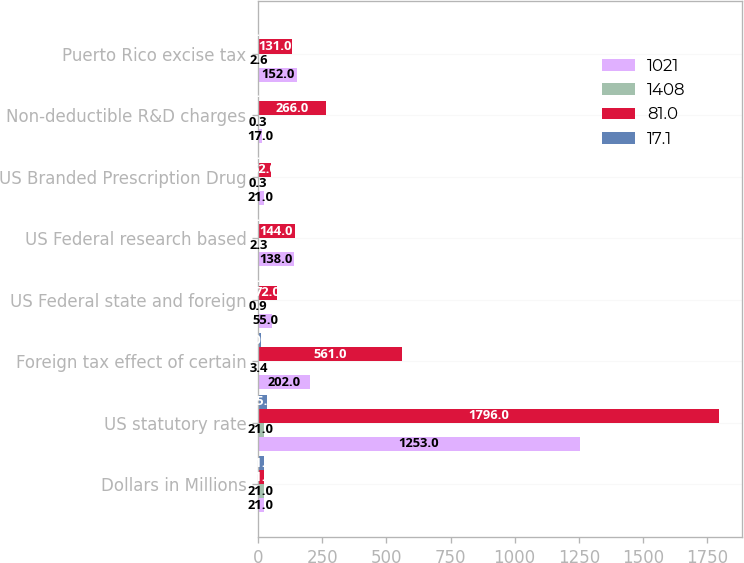Convert chart. <chart><loc_0><loc_0><loc_500><loc_500><stacked_bar_chart><ecel><fcel>Dollars in Millions<fcel>US statutory rate<fcel>Foreign tax effect of certain<fcel>US Federal state and foreign<fcel>US Federal research based<fcel>US Branded Prescription Drug<fcel>Non-deductible R&D charges<fcel>Puerto Rico excise tax<nl><fcel>1021<fcel>21<fcel>1253<fcel>202<fcel>55<fcel>138<fcel>21<fcel>17<fcel>152<nl><fcel>1408<fcel>21<fcel>21<fcel>3.4<fcel>0.9<fcel>2.3<fcel>0.3<fcel>0.3<fcel>2.6<nl><fcel>81<fcel>21<fcel>1796<fcel>561<fcel>72<fcel>144<fcel>52<fcel>266<fcel>131<nl><fcel>17.1<fcel>21<fcel>35<fcel>10.9<fcel>1.4<fcel>2.8<fcel>1<fcel>5.2<fcel>2.6<nl></chart> 